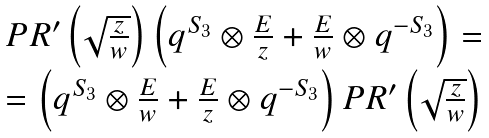<formula> <loc_0><loc_0><loc_500><loc_500>\begin{array} { c } { { P R ^ { \prime } \left ( \sqrt { \frac { z } { w } } \right ) \left ( q ^ { S _ { 3 } } \otimes { \frac { E } { z } } + { \frac { E } { w } } \otimes q ^ { - S _ { 3 } } \right ) = } } \\ { { = \left ( q ^ { S _ { 3 } } \otimes { \frac { E } { w } } + { \frac { E } { z } } \otimes q ^ { - S _ { 3 } } \right ) P R ^ { \prime } \left ( \sqrt { \frac { z } { w } } \right ) } } \end{array}</formula> 